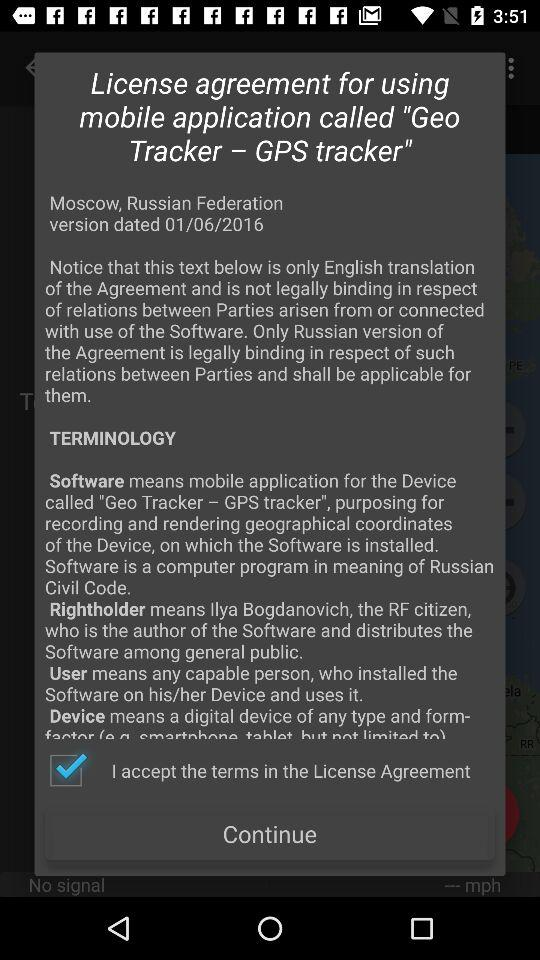What is the version date? The version date is January 6, 2016. 